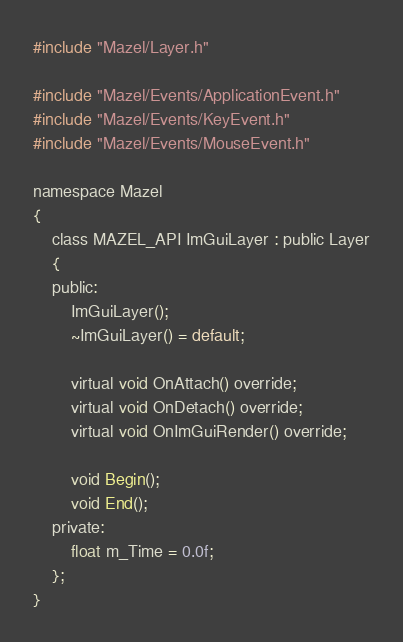<code> <loc_0><loc_0><loc_500><loc_500><_C_>#include "Mazel/Layer.h"

#include "Mazel/Events/ApplicationEvent.h"
#include "Mazel/Events/KeyEvent.h"
#include "Mazel/Events/MouseEvent.h"

namespace Mazel
{
	class MAZEL_API ImGuiLayer : public Layer
	{
	public:
		ImGuiLayer();
		~ImGuiLayer() = default;

		virtual void OnAttach() override;
		virtual void OnDetach() override;
		virtual void OnImGuiRender() override;

		void Begin();
		void End();
	private:
		float m_Time = 0.0f;
	};
}

</code> 